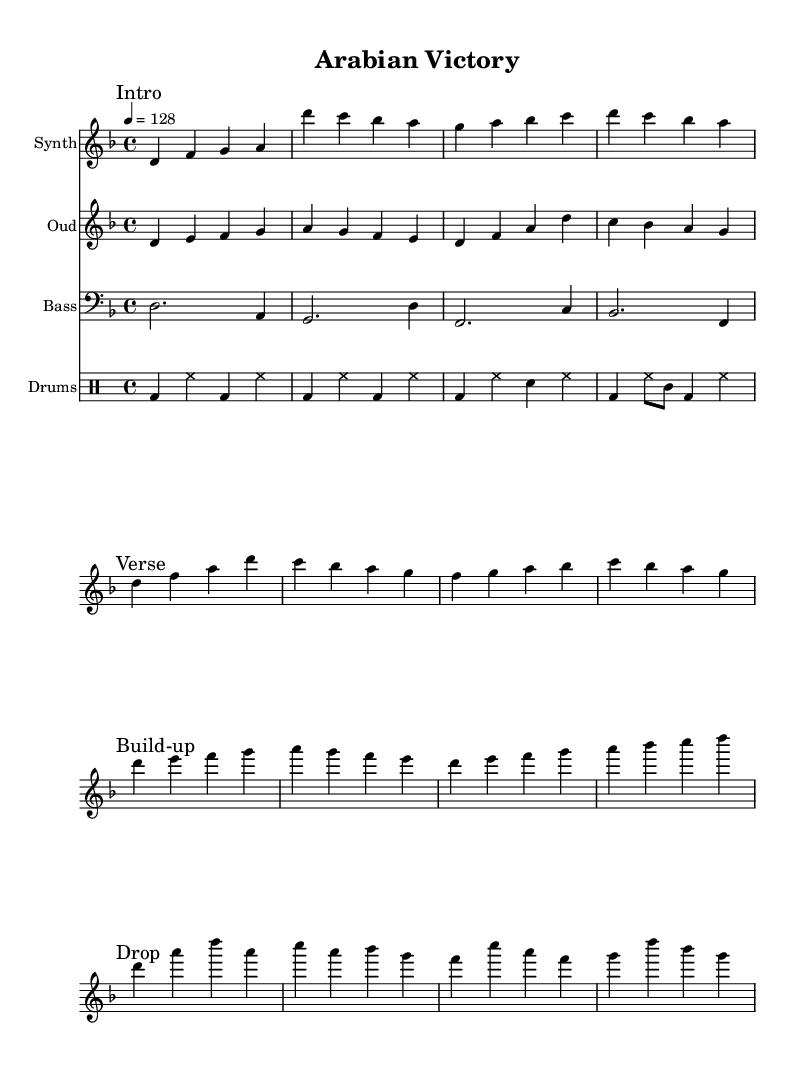What is the key signature of this music? The key signature indicates that the piece is in D minor, as shown by the one flat (B flat) at the beginning of the staff.
Answer: D minor What is the time signature of this music? The time signature is noted as 4/4 on the staff, which means there are four beats in each measure and a quarter note gets one beat.
Answer: 4/4 What is the tempo marking of this piece? The tempo is indicated as 4 = 128, meaning there are 128 beats per minute for the quarter note.
Answer: 128 What is the first section of the music called? The first section is marked as "Intro," which is visible at the start of the first section.
Answer: Intro How many measures does the "Build-up" section contain? The "Build-up" section consists of four measures, as indicated by the notation before the break.
Answer: 4 What role does the "Oud" play in this piece? The "Oud" plays a melodic riff, indicated by the staff labeled "Oud" which is distinct from the other instrumental sections.
Answer: Melodic riff Which section features a significant drop in energy? The section labeled as "Drop" is specifically noted to contrast the preceding sections with an energetic climax.
Answer: Drop 